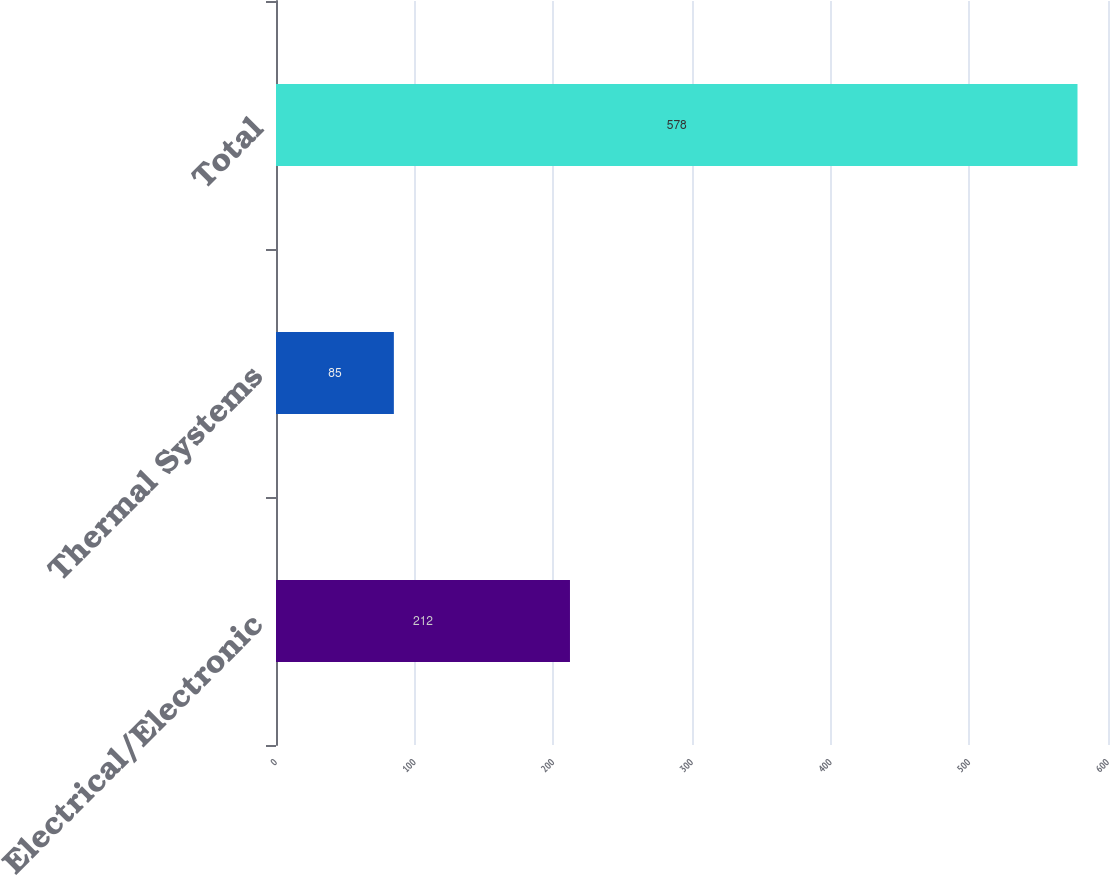<chart> <loc_0><loc_0><loc_500><loc_500><bar_chart><fcel>Electrical/Electronic<fcel>Thermal Systems<fcel>Total<nl><fcel>212<fcel>85<fcel>578<nl></chart> 